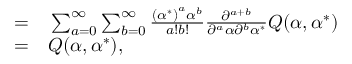<formula> <loc_0><loc_0><loc_500><loc_500>\begin{array} { r l } { = } & \sum _ { a = 0 } ^ { \infty } \sum _ { b = 0 } ^ { \infty } \frac { \left ( { \alpha ^ { * } } \right ) ^ { a } \alpha ^ { b } } { a ! b ! } \frac { \partial ^ { a + b } } { \partial ^ { a } \alpha \partial ^ { b } \alpha ^ { * } } Q ( \alpha , \alpha ^ { * } ) } \\ { = } & Q ( \alpha , \alpha ^ { * } ) , } \end{array}</formula> 